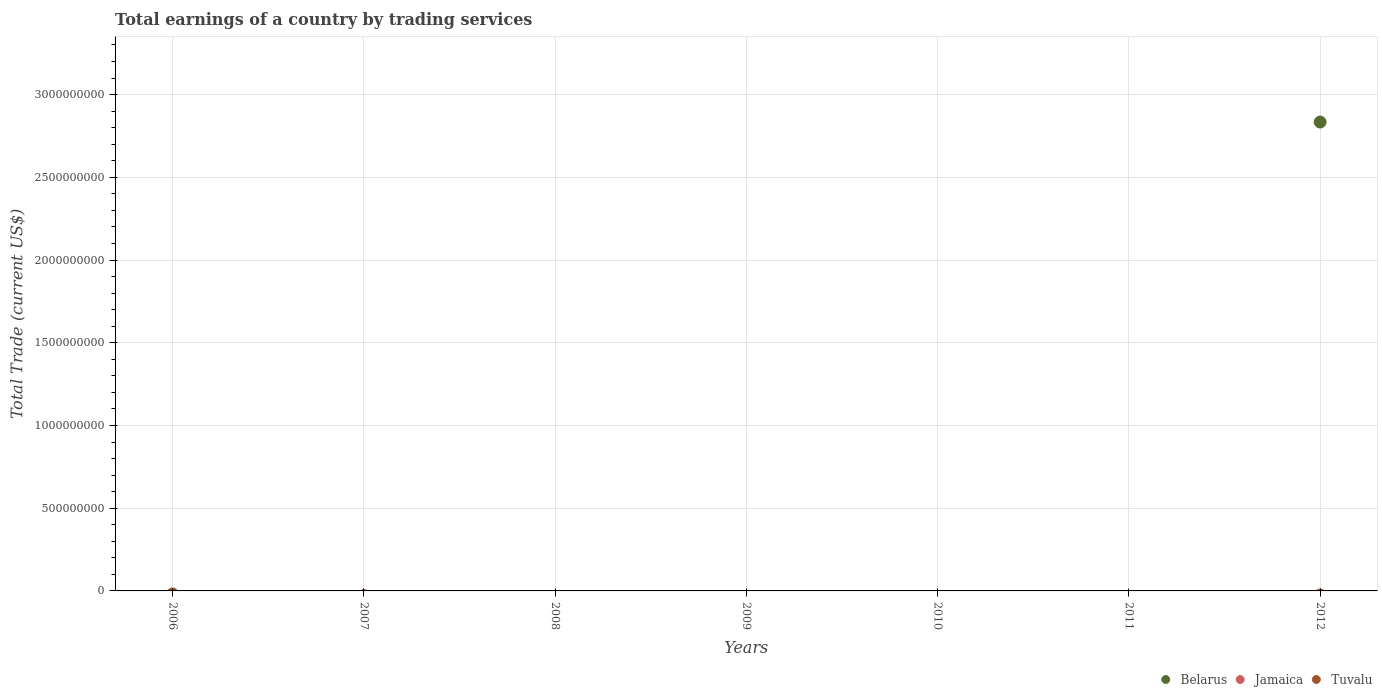How many different coloured dotlines are there?
Your answer should be compact. 1. Is the number of dotlines equal to the number of legend labels?
Give a very brief answer. No. Across all years, what is the maximum total earnings in Belarus?
Make the answer very short. 2.83e+09. Across all years, what is the minimum total earnings in Belarus?
Ensure brevity in your answer.  0. In which year was the total earnings in Belarus maximum?
Your response must be concise. 2012. What is the difference between the highest and the lowest total earnings in Belarus?
Your answer should be compact. 2.83e+09. In how many years, is the total earnings in Tuvalu greater than the average total earnings in Tuvalu taken over all years?
Your answer should be very brief. 0. Does the total earnings in Tuvalu monotonically increase over the years?
Ensure brevity in your answer.  No. Is the total earnings in Jamaica strictly greater than the total earnings in Tuvalu over the years?
Make the answer very short. No. What is the difference between two consecutive major ticks on the Y-axis?
Your answer should be very brief. 5.00e+08. Does the graph contain any zero values?
Keep it short and to the point. Yes. Does the graph contain grids?
Ensure brevity in your answer.  Yes. Where does the legend appear in the graph?
Your response must be concise. Bottom right. How are the legend labels stacked?
Give a very brief answer. Horizontal. What is the title of the graph?
Give a very brief answer. Total earnings of a country by trading services. Does "St. Martin (French part)" appear as one of the legend labels in the graph?
Provide a short and direct response. No. What is the label or title of the Y-axis?
Your response must be concise. Total Trade (current US$). What is the Total Trade (current US$) of Belarus in 2006?
Offer a very short reply. 0. What is the Total Trade (current US$) in Jamaica in 2006?
Your answer should be compact. 0. What is the Total Trade (current US$) of Tuvalu in 2006?
Offer a very short reply. 0. What is the Total Trade (current US$) in Jamaica in 2007?
Your response must be concise. 0. What is the Total Trade (current US$) of Tuvalu in 2008?
Provide a short and direct response. 0. What is the Total Trade (current US$) of Jamaica in 2009?
Keep it short and to the point. 0. What is the Total Trade (current US$) in Tuvalu in 2009?
Keep it short and to the point. 0. What is the Total Trade (current US$) in Jamaica in 2010?
Provide a succinct answer. 0. What is the Total Trade (current US$) of Belarus in 2011?
Ensure brevity in your answer.  0. What is the Total Trade (current US$) of Belarus in 2012?
Give a very brief answer. 2.83e+09. What is the Total Trade (current US$) in Tuvalu in 2012?
Keep it short and to the point. 0. Across all years, what is the maximum Total Trade (current US$) of Belarus?
Ensure brevity in your answer.  2.83e+09. Across all years, what is the minimum Total Trade (current US$) in Belarus?
Offer a very short reply. 0. What is the total Total Trade (current US$) of Belarus in the graph?
Give a very brief answer. 2.83e+09. What is the total Total Trade (current US$) in Jamaica in the graph?
Offer a very short reply. 0. What is the total Total Trade (current US$) in Tuvalu in the graph?
Provide a short and direct response. 0. What is the average Total Trade (current US$) in Belarus per year?
Offer a terse response. 4.05e+08. What is the average Total Trade (current US$) in Tuvalu per year?
Give a very brief answer. 0. What is the difference between the highest and the lowest Total Trade (current US$) of Belarus?
Offer a very short reply. 2.83e+09. 